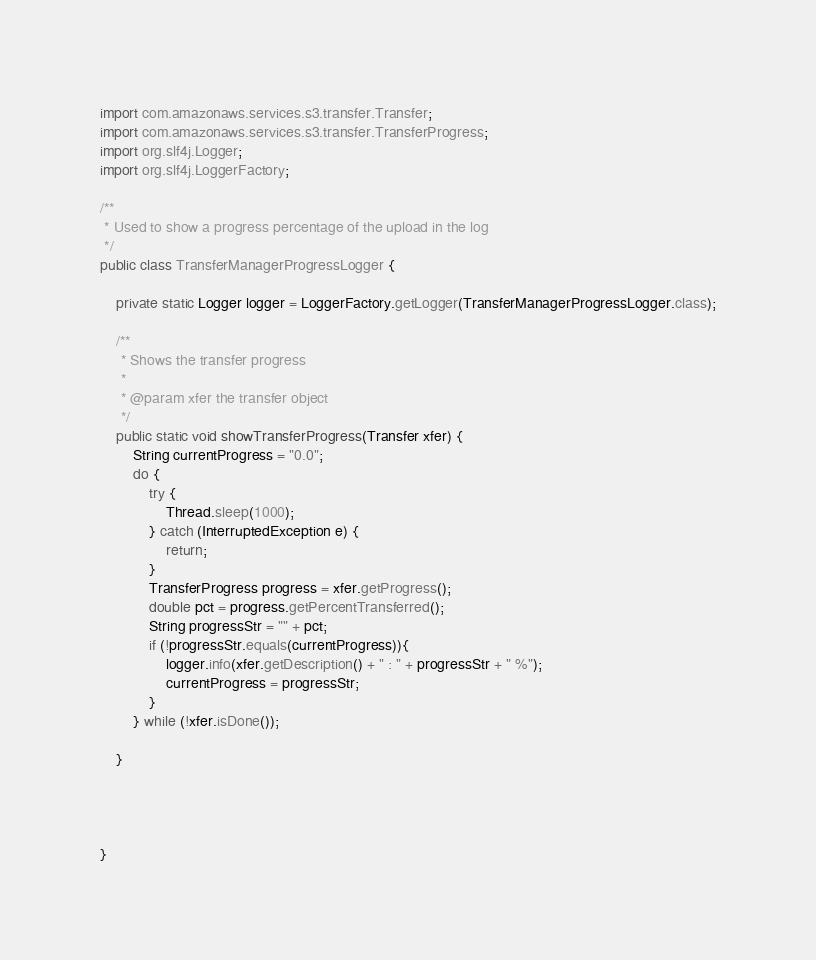<code> <loc_0><loc_0><loc_500><loc_500><_Java_>import com.amazonaws.services.s3.transfer.Transfer;
import com.amazonaws.services.s3.transfer.TransferProgress;
import org.slf4j.Logger;
import org.slf4j.LoggerFactory;

/**
 * Used to show a progress percentage of the upload in the log
 */
public class TransferManagerProgressLogger {

    private static Logger logger = LoggerFactory.getLogger(TransferManagerProgressLogger.class);

    /**
     * Shows the transfer progress
     *
     * @param xfer the transfer object
     */
    public static void showTransferProgress(Transfer xfer) {
        String currentProgress = "0.0";
        do {
            try {
                Thread.sleep(1000);
            } catch (InterruptedException e) {
                return;
            }
            TransferProgress progress = xfer.getProgress();
            double pct = progress.getPercentTransferred();
            String progressStr = "" + pct;
            if (!progressStr.equals(currentProgress)){
                logger.info(xfer.getDescription() + " : " + progressStr + " %");
                currentProgress = progressStr;
            }
        } while (!xfer.isDone());

    }




}
</code> 